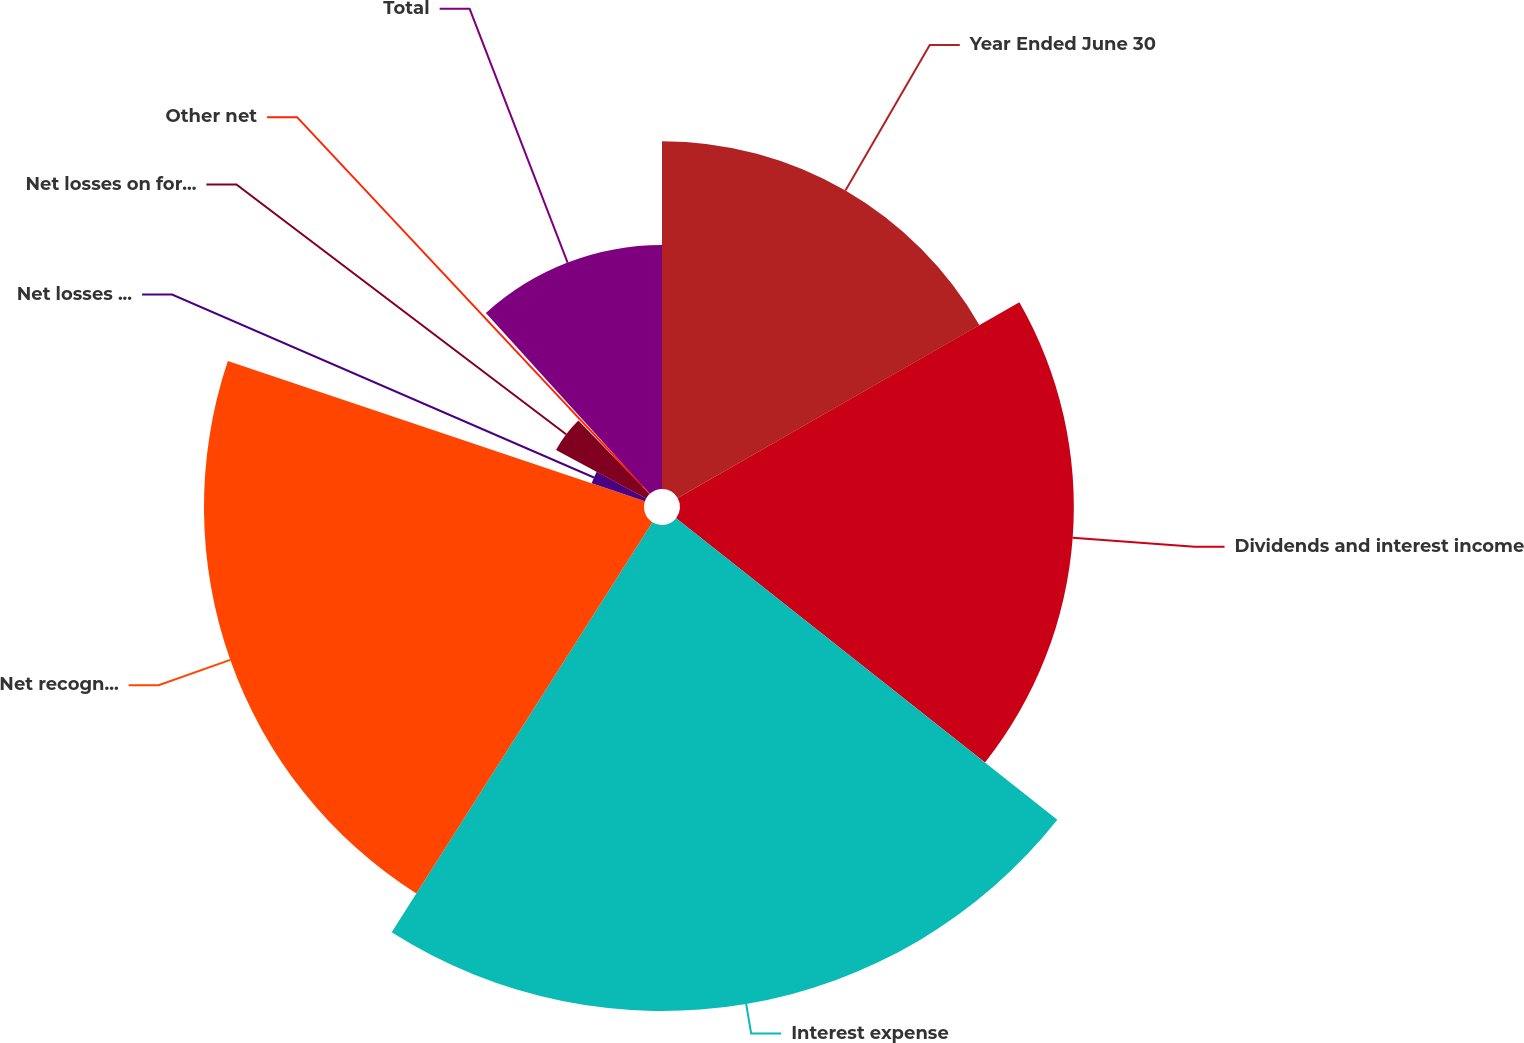Convert chart to OTSL. <chart><loc_0><loc_0><loc_500><loc_500><pie_chart><fcel>Year Ended June 30<fcel>Dividends and interest income<fcel>Interest expense<fcel>Net recognized gains on<fcel>Net losses on derivatives<fcel>Net losses on foreign currency<fcel>Other net<fcel>Total<nl><fcel>16.72%<fcel>18.93%<fcel>23.36%<fcel>21.15%<fcel>2.7%<fcel>4.92%<fcel>0.49%<fcel>11.73%<nl></chart> 